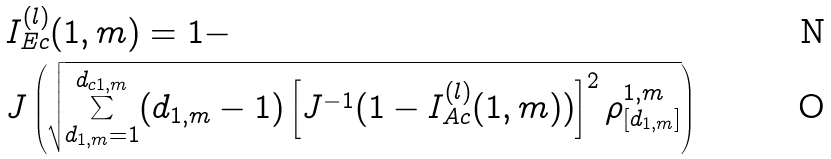Convert formula to latex. <formula><loc_0><loc_0><loc_500><loc_500>& I _ { E c } ^ { ( l ) } ( 1 , m ) = 1 - \\ & J \left ( \sqrt { \underset { d _ { 1 , m } = 1 } { \overset { d _ { c 1 , m } } { \boldsymbol \sum } } ( d _ { 1 , m } - 1 ) \left [ J ^ { - 1 } ( 1 - I _ { A c } ^ { ( l ) } ( 1 , m ) ) \right ] ^ { 2 } \rho _ { [ d _ { 1 , m } ] } ^ { 1 , m } } \right )</formula> 